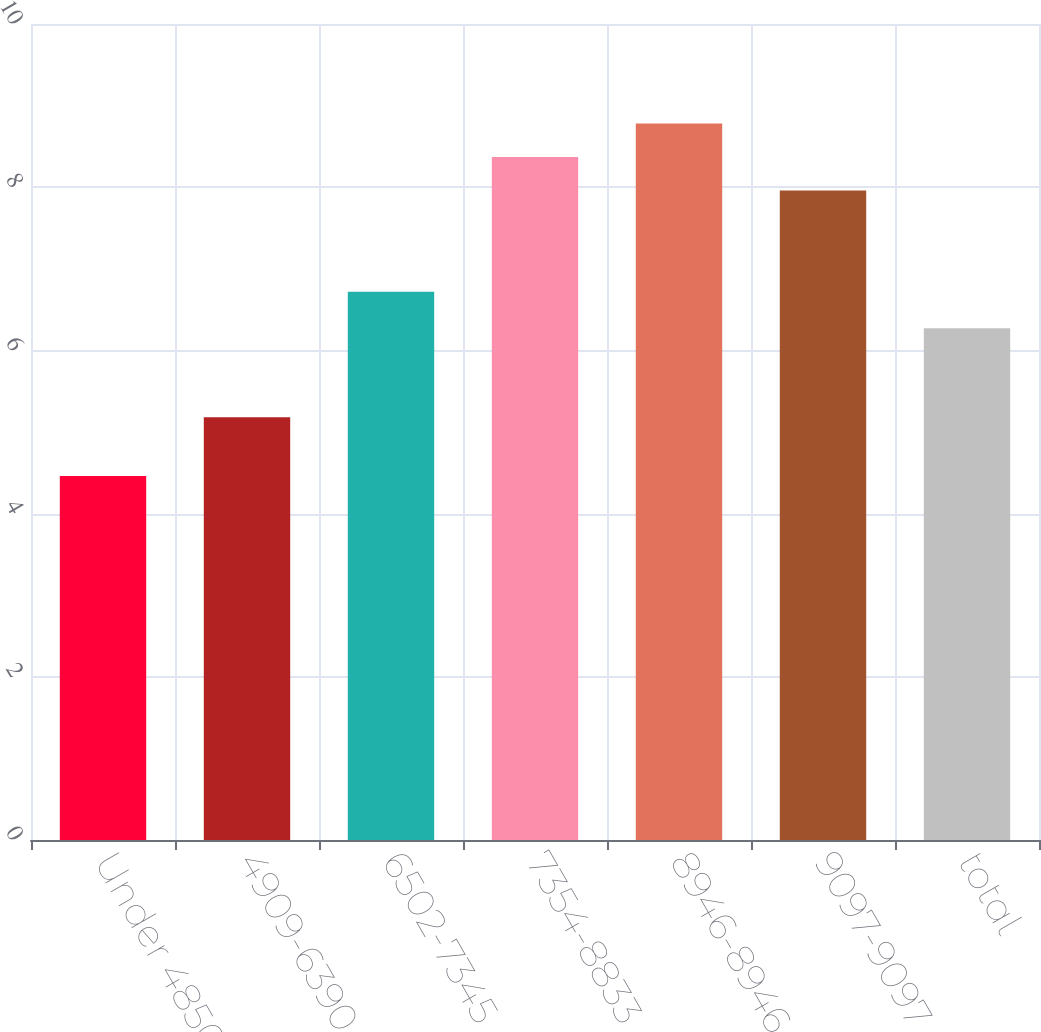<chart> <loc_0><loc_0><loc_500><loc_500><bar_chart><fcel>Under 4850<fcel>4909-6390<fcel>6502-7345<fcel>7354-8833<fcel>8946-8946<fcel>9097-9097<fcel>total<nl><fcel>4.46<fcel>5.18<fcel>6.72<fcel>8.37<fcel>8.78<fcel>7.96<fcel>6.27<nl></chart> 